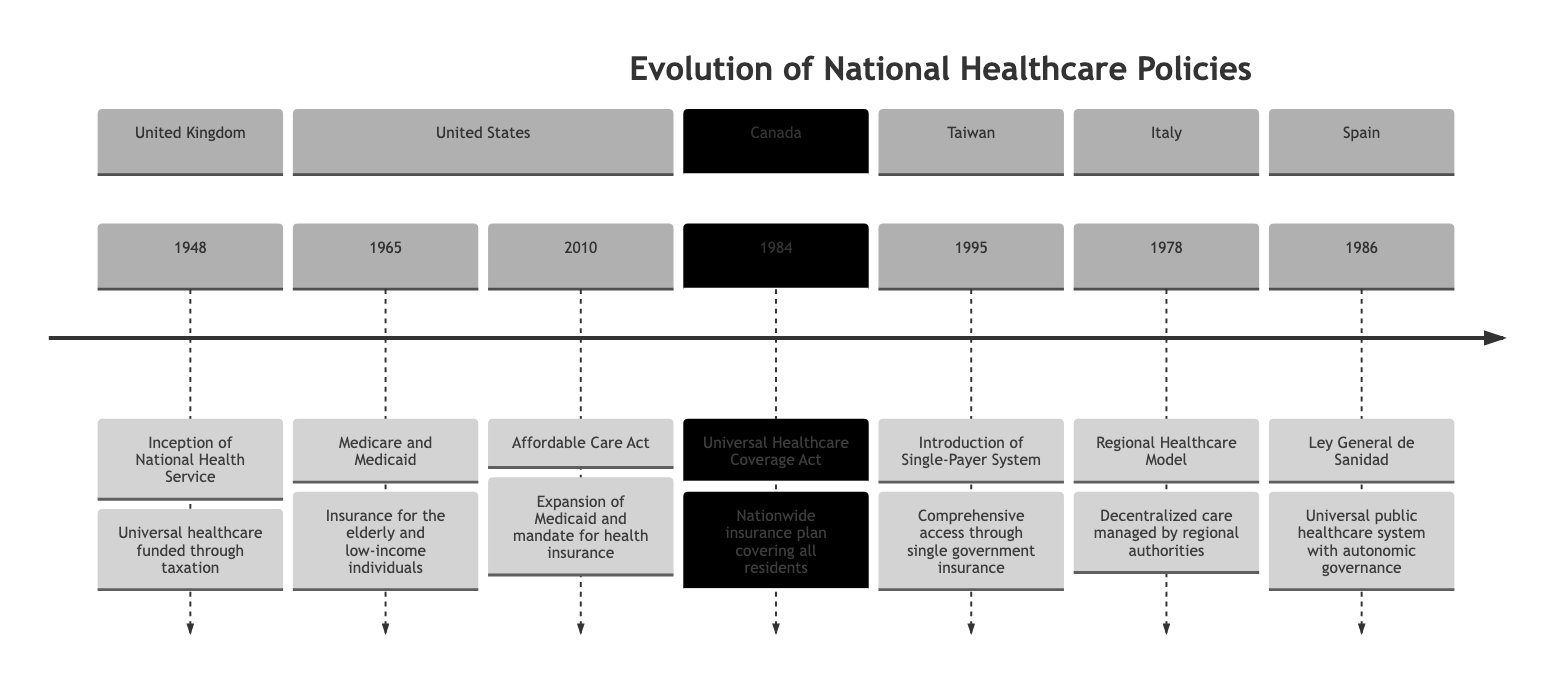What year was the Inception of National Health Service? The diagram indicates that the Inception of the National Health Service occurred in 1948 in the United Kingdom.
Answer: 1948 Which country implemented the Affordable Care Act? The diagram shows that the Affordable Care Act was implemented in the United States as indicated in the relevant section.
Answer: United States How many healthcare policies are listed for the United States? By examining the United States section of the diagram, it can be noted that there are two policies: Medicare and Medicaid (1965) and the Affordable Care Act (2010).
Answer: 2 What is the key focus of the Universal Healthcare Coverage Act? The diagram states that the key focus of the Universal Healthcare Coverage Act is a nationwide insurance plan covering all residents in Canada.
Answer: Nationwide insurance plan covering all residents Which country introduced a single-payer system in 1995? The Taiwan section of the diagram reveals the introduction of a single-payer system in the year 1995.
Answer: Taiwan What was the key focus of the Regional Healthcare Model in Italy? According to the diagram, the key focus of the Regional Healthcare Model is decentralized care managed by regional authorities.
Answer: Decentralized care managed by regional authorities Which healthcare policy is associated with the year 1986? The Ley General de Sanidad is the policy associated with the year 1986, as per the Spain section of the diagram.
Answer: Ley General de Sanidad What commonality can be found in healthcare policies from both Canada and Spain? Both Canada and Spain's policies focus on universal healthcare systems, as indicated in their respective sections in the diagram.
Answer: Universal healthcare systems Which country had its significant healthcare policy established earlier, Italy or Canada? By comparing the years, Italy's Regional Healthcare Model was established in 1978, whereas Canada’s Universal Healthcare Coverage Act was established in 1984. Since 1978 is earlier than 1984, Italy had its significant policy established first.
Answer: Italy 